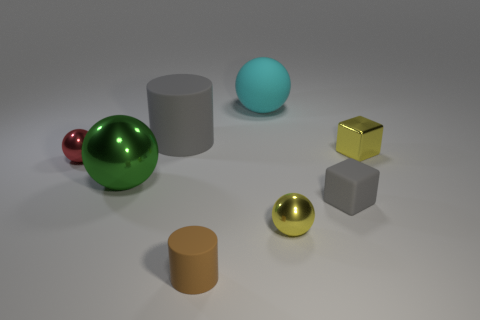How many other objects are the same shape as the large cyan object?
Keep it short and to the point. 3. There is a yellow object right of the small gray block; does it have the same shape as the large thing that is in front of the red metallic ball?
Offer a very short reply. No. What is the shape of the tiny rubber object that is the same color as the big rubber cylinder?
Make the answer very short. Cube. What color is the small metallic object in front of the gray matte object that is on the right side of the large gray cylinder?
Offer a terse response. Yellow. What is the color of the small matte object that is the same shape as the big gray object?
Offer a very short reply. Brown. Are there any other things that are the same material as the small yellow block?
Provide a short and direct response. Yes. What size is the gray rubber object that is the same shape as the brown object?
Provide a succinct answer. Large. What material is the tiny sphere that is behind the gray block?
Offer a terse response. Metal. Are there fewer matte balls in front of the green ball than tiny things?
Your answer should be compact. Yes. There is a large object that is behind the cylinder that is to the left of the tiny cylinder; what is its shape?
Give a very brief answer. Sphere. 